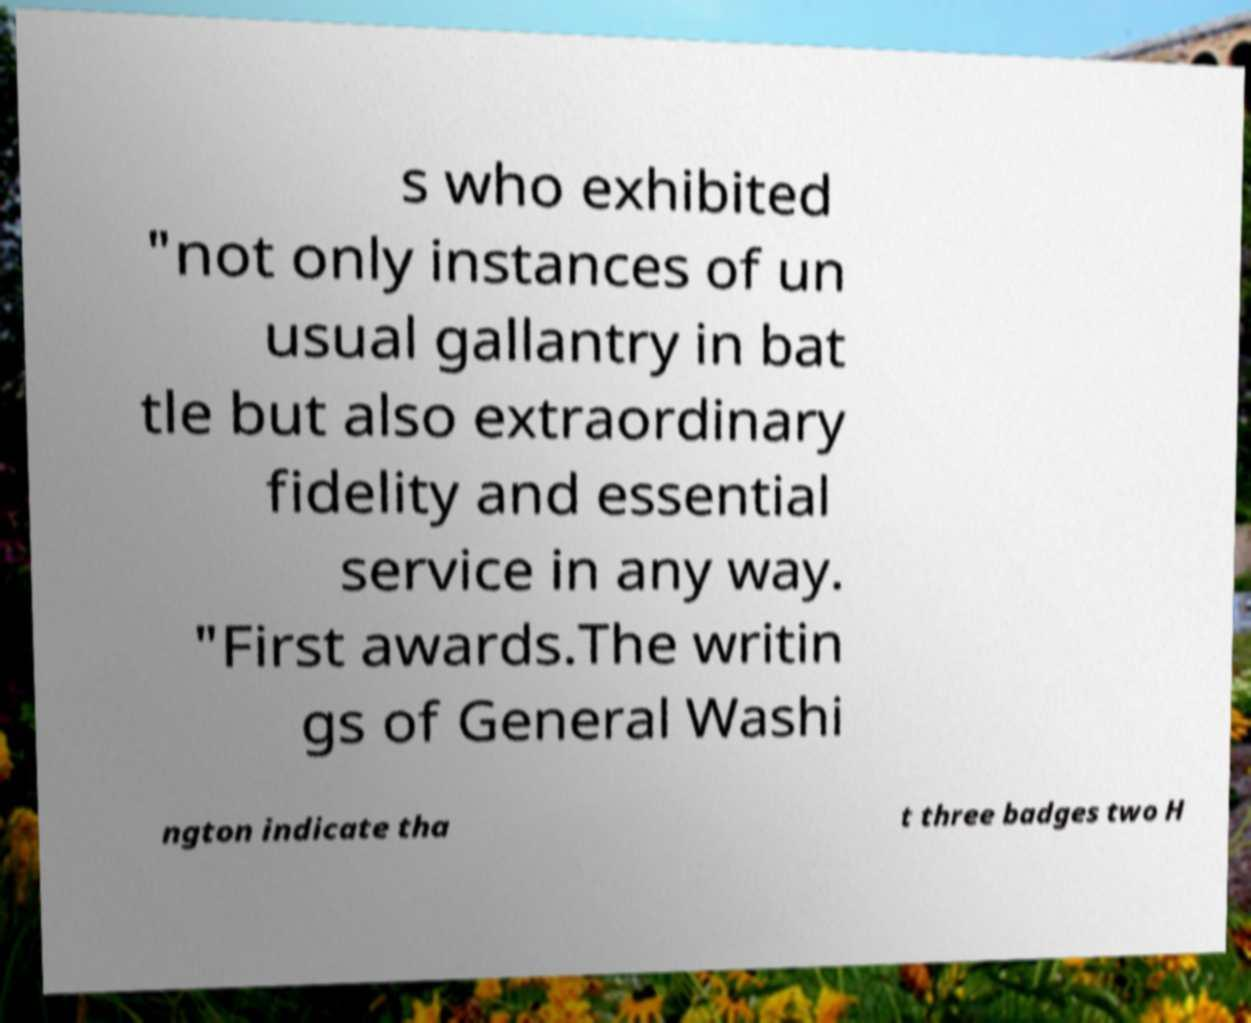Please read and relay the text visible in this image. What does it say? s who exhibited "not only instances of un usual gallantry in bat tle but also extraordinary fidelity and essential service in any way. "First awards.The writin gs of General Washi ngton indicate tha t three badges two H 